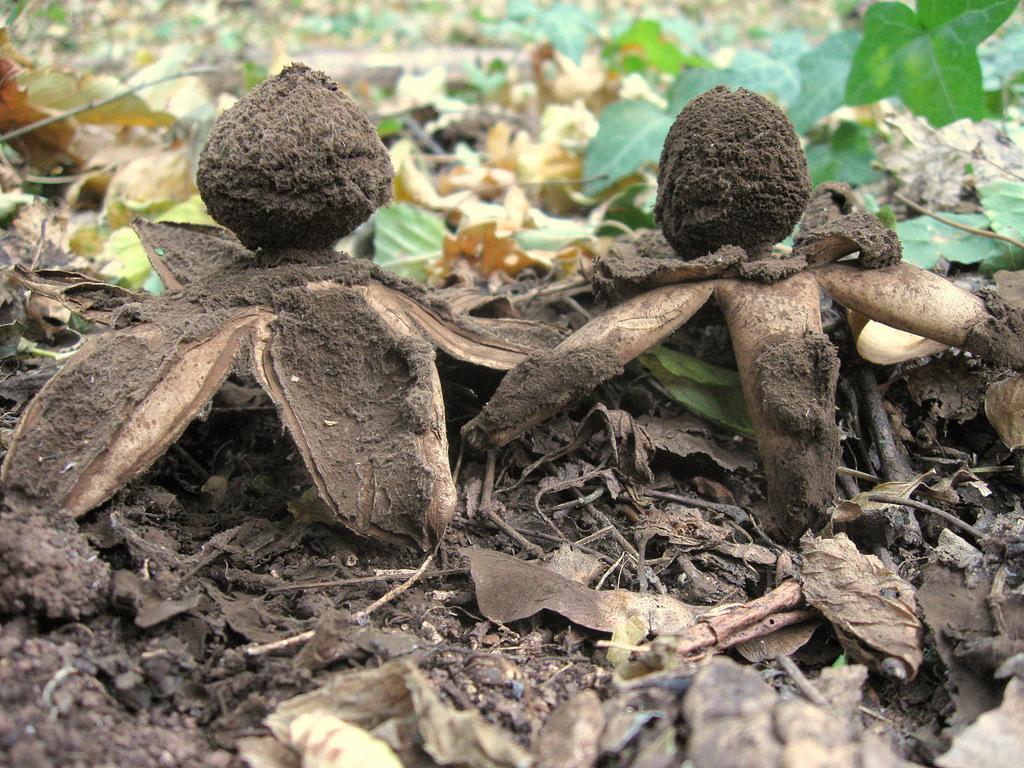Describe this image in one or two sentences. In this picture we can see few earth stars and leaves. 